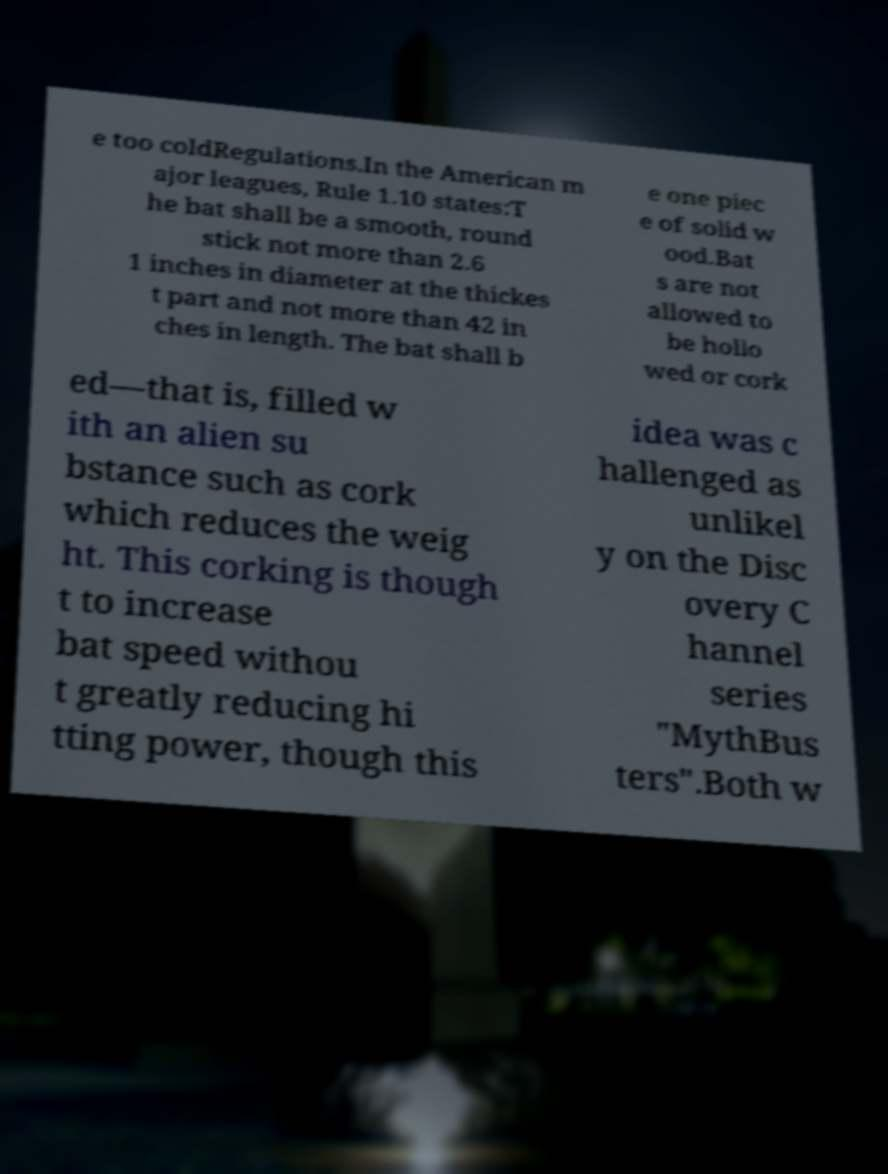Could you extract and type out the text from this image? e too coldRegulations.In the American m ajor leagues, Rule 1.10 states:T he bat shall be a smooth, round stick not more than 2.6 1 inches in diameter at the thickes t part and not more than 42 in ches in length. The bat shall b e one piec e of solid w ood.Bat s are not allowed to be hollo wed or cork ed—that is, filled w ith an alien su bstance such as cork which reduces the weig ht. This corking is though t to increase bat speed withou t greatly reducing hi tting power, though this idea was c hallenged as unlikel y on the Disc overy C hannel series "MythBus ters".Both w 